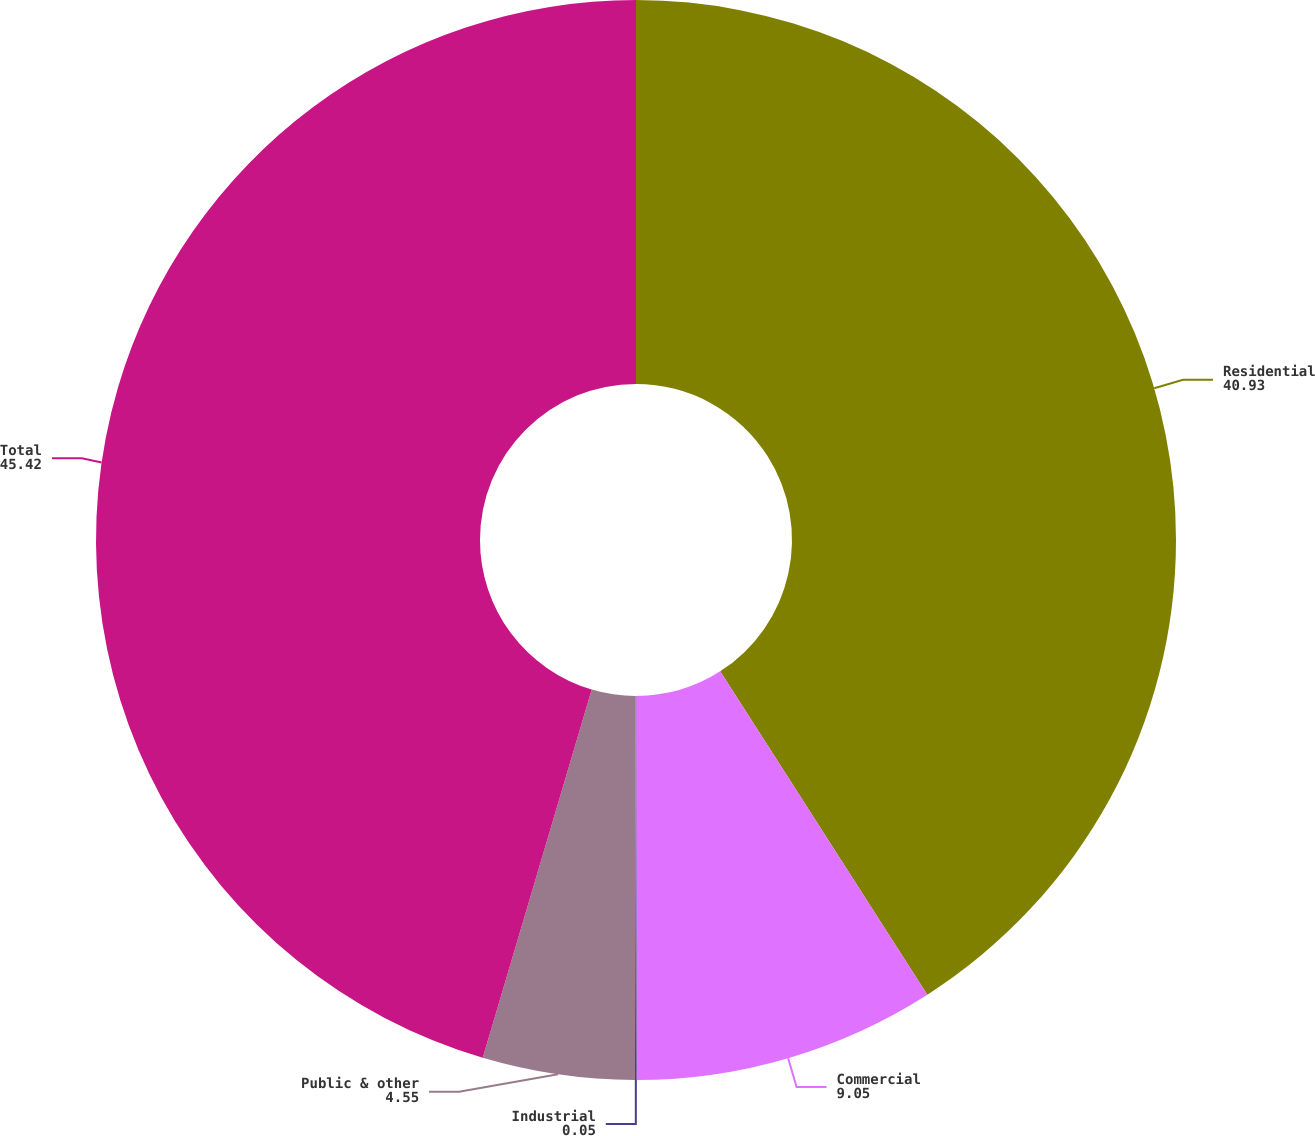Convert chart to OTSL. <chart><loc_0><loc_0><loc_500><loc_500><pie_chart><fcel>Residential<fcel>Commercial<fcel>Industrial<fcel>Public & other<fcel>Total<nl><fcel>40.93%<fcel>9.05%<fcel>0.05%<fcel>4.55%<fcel>45.42%<nl></chart> 